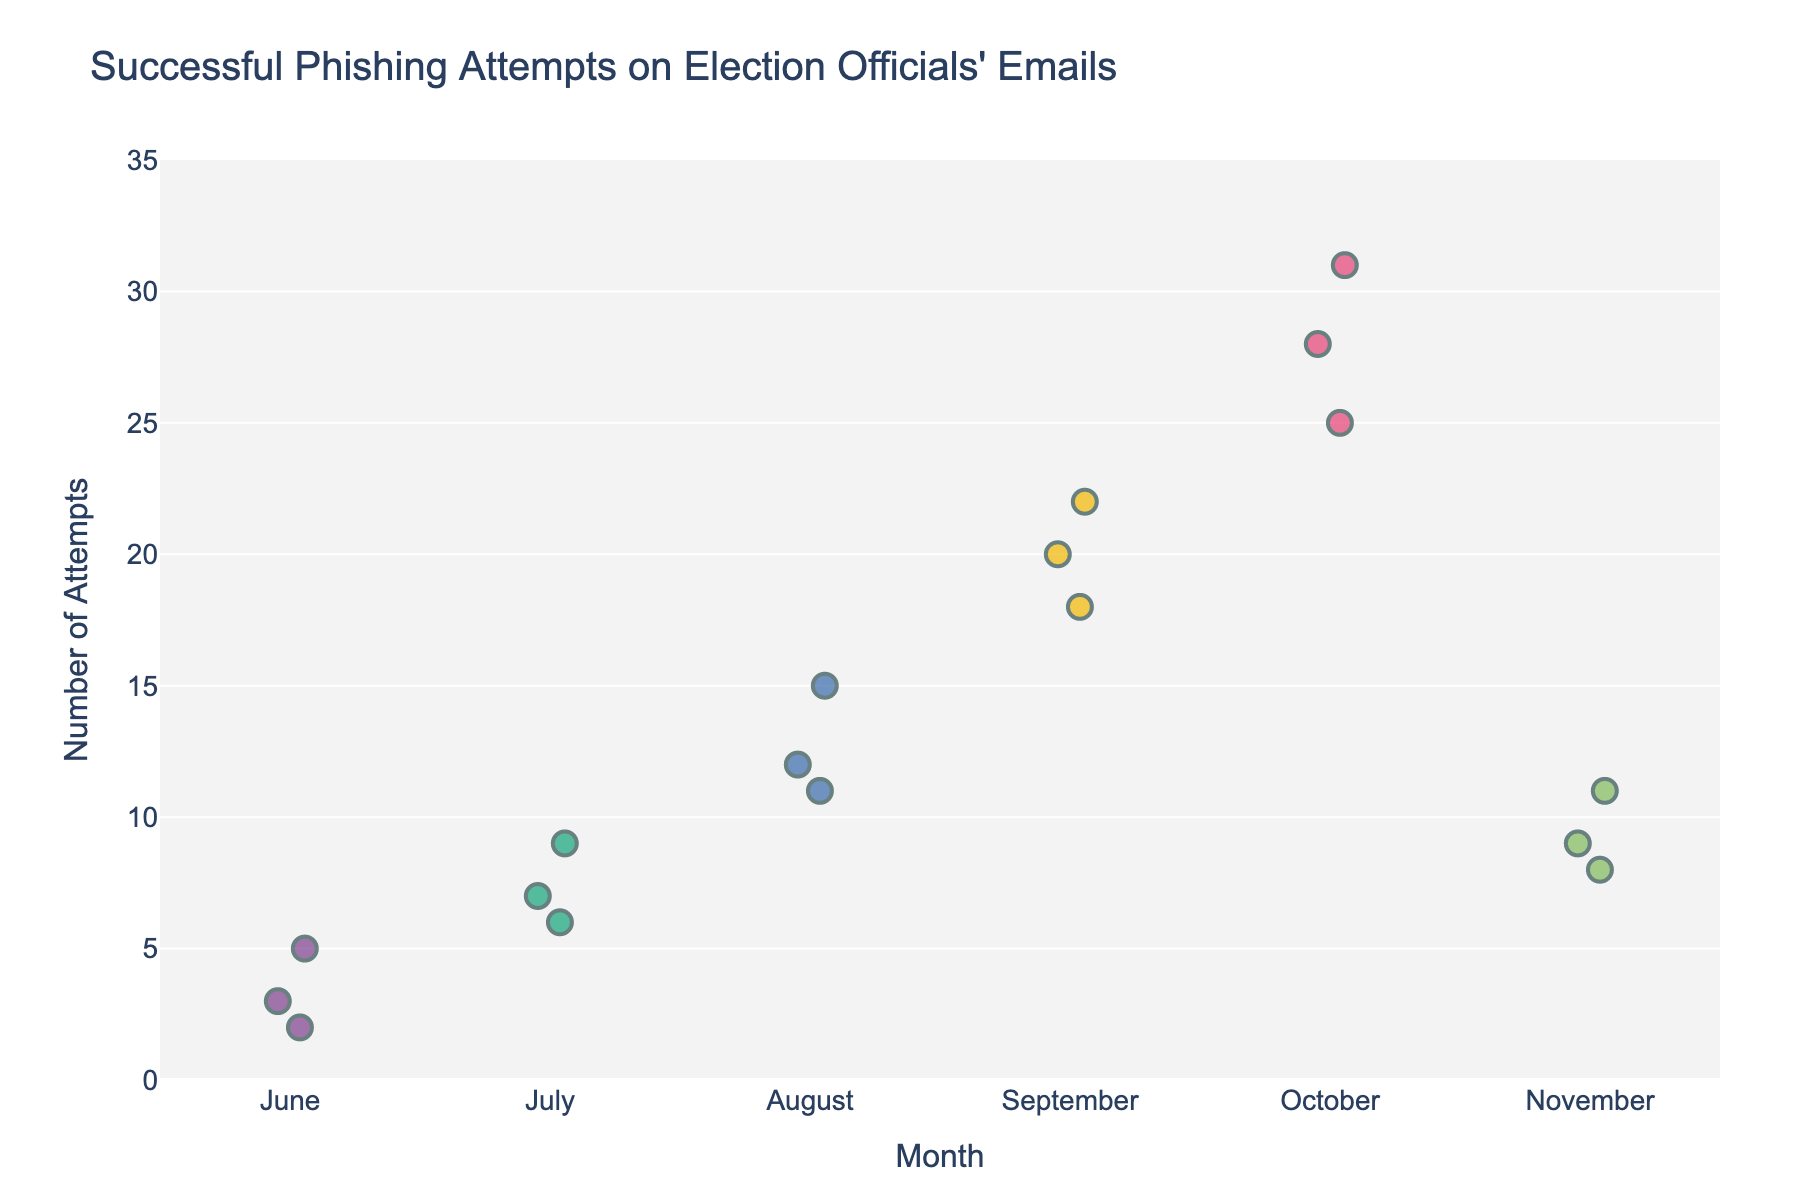What is the title of the figure? The title is located at the top of the figure, indicating what the graph represents. To find it, refer to the text in the center upper part of the plot.
Answer: Successful Phishing Attempts on Election Officials' Emails What is the range of the y-axis in the figure? The range of the y-axis can be determined by looking at the scale on the left side of the plot. It shows the minimum and maximum values represented on the graph.
Answer: 0 to 35 In which month did the highest number of successful phishing attempts occur? Identify the cluster of points that reach the highest value on the y-axis. Look at the corresponding x-axis label to determine the month.
Answer: October How many successful phishing attempts were recorded in August? Count all the individual points aligned with the "August" label on the x-axis. Each point represents one recorded phishing attempt.
Answer: 3 What can you observe about the trend of successful phishing attempts from June to October? Look at the overall distribution and position of points along the y-axis as you move from June to October. Note any patterns, such as increasing values.
Answer: Increasing trend Compare the median number of successful phishing attempts in September and October. Which month has a higher median? First, arrange the data points for each month in ascending order. Then find the middle value for both months (median).
Answer: October What is the average number of successful phishing attempts in July? Sum the values of phishing attempts in July and divide by the number of data points to calculate the average. The values are 7, 9, and 6. Average = (7+9+6)/3.
Answer: 7.33 Are there any months where successful phishing attempts consistently decrease? Examine each month's data points and compare their values month by month to see if there's any consistent decrease.
Answer: No By how much did the highest successful phishing attempt in October exceed the highest attempt in September? Identify the highest value in October and compare it to the highest value in September. Subtract the September value from the October value.
Answer: 9 What might be suggested by the clustering of points in October compared to earlier months? Observe the density and spread of the data points in October. Compared to earlier months, note any significant differences in clustering or spread.
Answer: Increased phishing attempts 